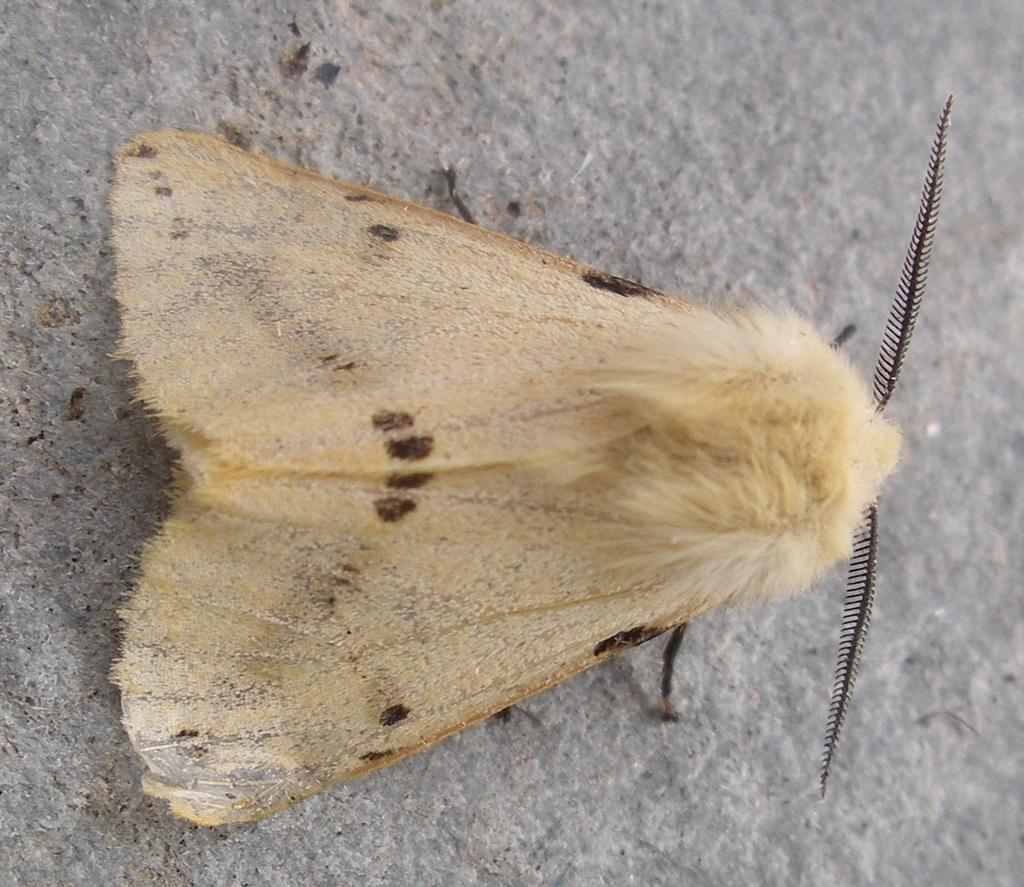What type of insect is present in the image? There is a moth in the image. What type of hair can be seen on the moth in the image? There is no hair present on the moth in the image, as moths are insects and do not have hair. 